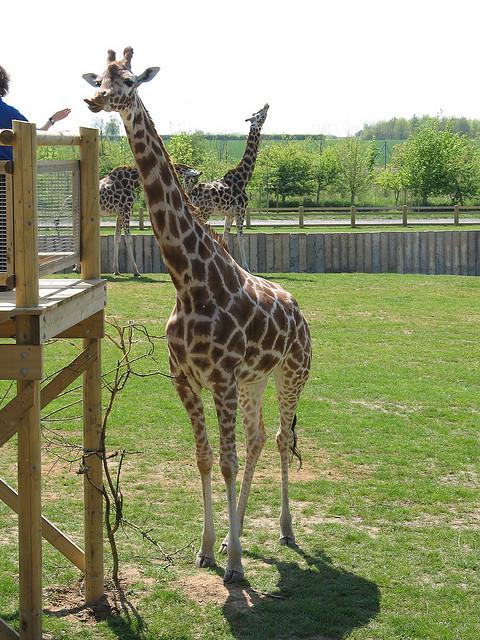What's on the raised platform on the left?
Keep it brief. Person. How many giraffes are in the picture?
Write a very short answer. 3. What are the animals standing on?
Be succinct. Grass. What is on the giraffe's head?
Quick response, please. Horns. Are they in a zoo?
Write a very short answer. Yes. Are the giraffes on alert?
Answer briefly. Yes. 